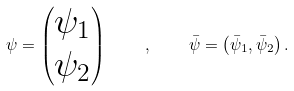Convert formula to latex. <formula><loc_0><loc_0><loc_500><loc_500>\psi = \left ( \begin{matrix} \psi _ { 1 } \\ \psi _ { 2 } \end{matrix} \right ) \quad , \quad \bar { \psi } = \left ( \bar { \psi } _ { 1 } , \bar { \psi } _ { 2 } \right ) .</formula> 